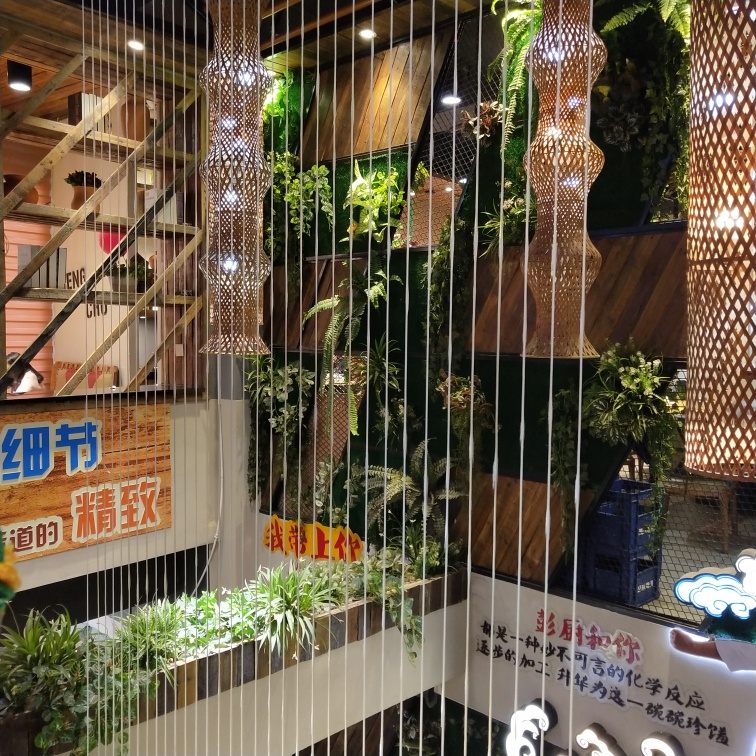How clear are the details of the advertising signs? The details on the advertising signs are very clear. With the image provided, the text on the signs is legible and the colors are distinctly visible, which suggests that the photo captures the details sharply. 